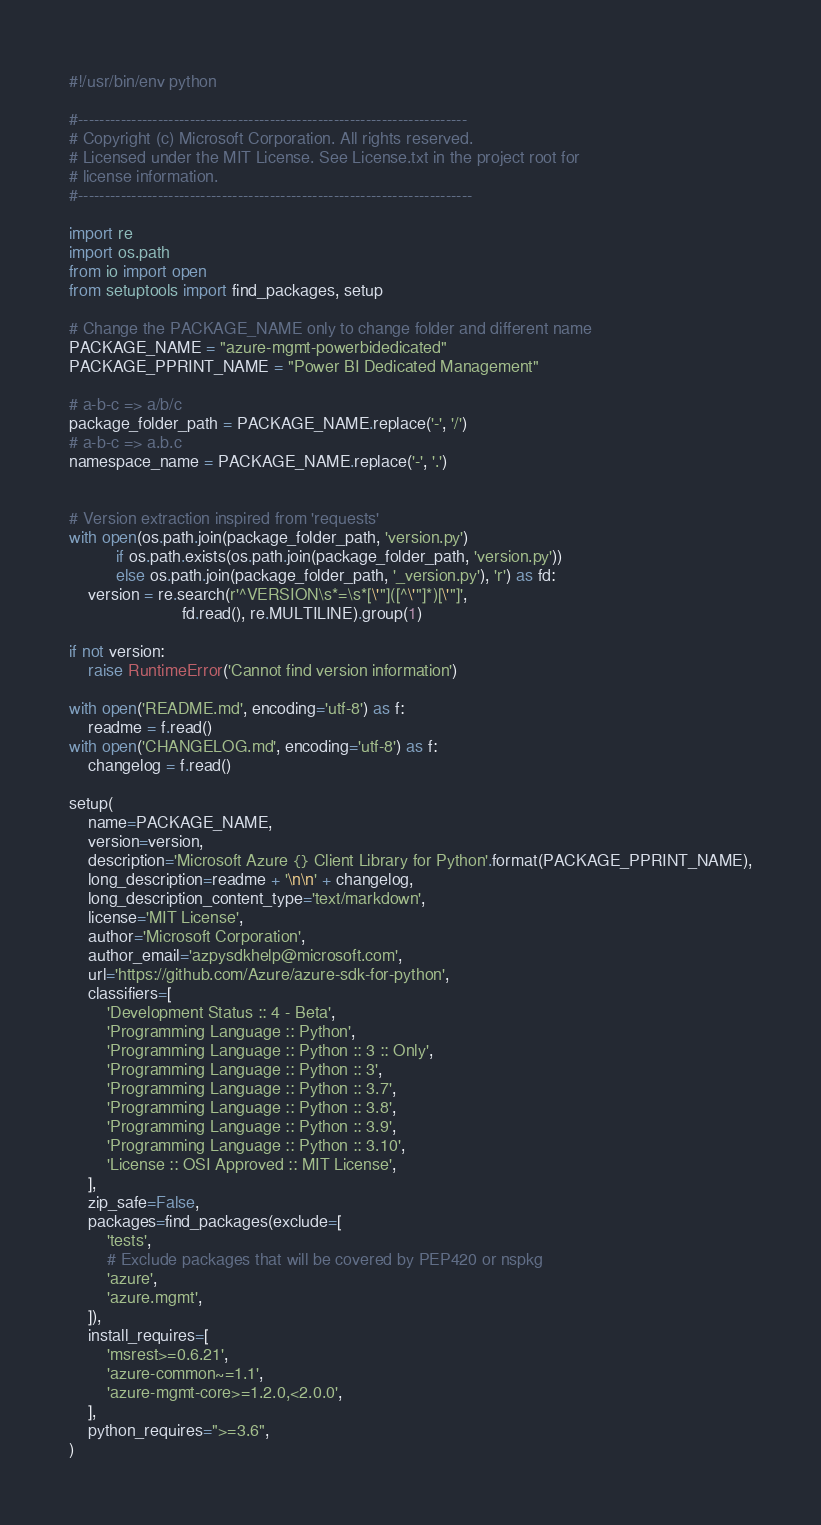<code> <loc_0><loc_0><loc_500><loc_500><_Python_>#!/usr/bin/env python

#-------------------------------------------------------------------------
# Copyright (c) Microsoft Corporation. All rights reserved.
# Licensed under the MIT License. See License.txt in the project root for
# license information.
#--------------------------------------------------------------------------

import re
import os.path
from io import open
from setuptools import find_packages, setup

# Change the PACKAGE_NAME only to change folder and different name
PACKAGE_NAME = "azure-mgmt-powerbidedicated"
PACKAGE_PPRINT_NAME = "Power BI Dedicated Management"

# a-b-c => a/b/c
package_folder_path = PACKAGE_NAME.replace('-', '/')
# a-b-c => a.b.c
namespace_name = PACKAGE_NAME.replace('-', '.')


# Version extraction inspired from 'requests'
with open(os.path.join(package_folder_path, 'version.py')
          if os.path.exists(os.path.join(package_folder_path, 'version.py'))
          else os.path.join(package_folder_path, '_version.py'), 'r') as fd:
    version = re.search(r'^VERSION\s*=\s*[\'"]([^\'"]*)[\'"]',
                        fd.read(), re.MULTILINE).group(1)

if not version:
    raise RuntimeError('Cannot find version information')

with open('README.md', encoding='utf-8') as f:
    readme = f.read()
with open('CHANGELOG.md', encoding='utf-8') as f:
    changelog = f.read()

setup(
    name=PACKAGE_NAME,
    version=version,
    description='Microsoft Azure {} Client Library for Python'.format(PACKAGE_PPRINT_NAME),
    long_description=readme + '\n\n' + changelog,
    long_description_content_type='text/markdown',
    license='MIT License',
    author='Microsoft Corporation',
    author_email='azpysdkhelp@microsoft.com',
    url='https://github.com/Azure/azure-sdk-for-python',
    classifiers=[
        'Development Status :: 4 - Beta',
        'Programming Language :: Python',
        'Programming Language :: Python :: 3 :: Only',
        'Programming Language :: Python :: 3',
        'Programming Language :: Python :: 3.7',
        'Programming Language :: Python :: 3.8',
        'Programming Language :: Python :: 3.9',
        'Programming Language :: Python :: 3.10',
        'License :: OSI Approved :: MIT License',
    ],
    zip_safe=False,
    packages=find_packages(exclude=[
        'tests',
        # Exclude packages that will be covered by PEP420 or nspkg
        'azure',
        'azure.mgmt',
    ]),
    install_requires=[
        'msrest>=0.6.21',
        'azure-common~=1.1',
        'azure-mgmt-core>=1.2.0,<2.0.0',
    ],
    python_requires=">=3.6",
)
</code> 